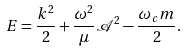Convert formula to latex. <formula><loc_0><loc_0><loc_500><loc_500>E = \frac { k ^ { 2 } } { 2 } + \frac { \omega ^ { 2 } } { \mu } { \mathcal { A } } ^ { 2 } - \frac { \omega _ { c } m } { 2 } .</formula> 